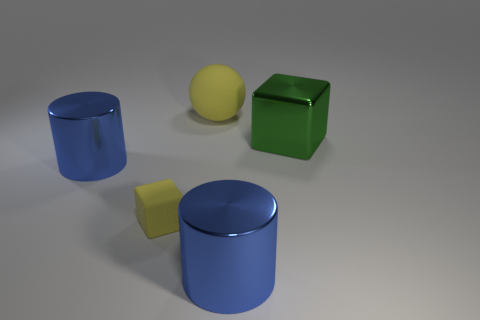If these objects were used in a physics education setting, what could students learn from them? Students could explore a range of concepts, including geometry and spatial relationships, the principles of reflection and refraction, material properties such as gloss and matte surfaces, and they could also perform experiments related to mass, density, and center of gravity by hypothesizing and then analyzing how the shapes would behave under different forces. 